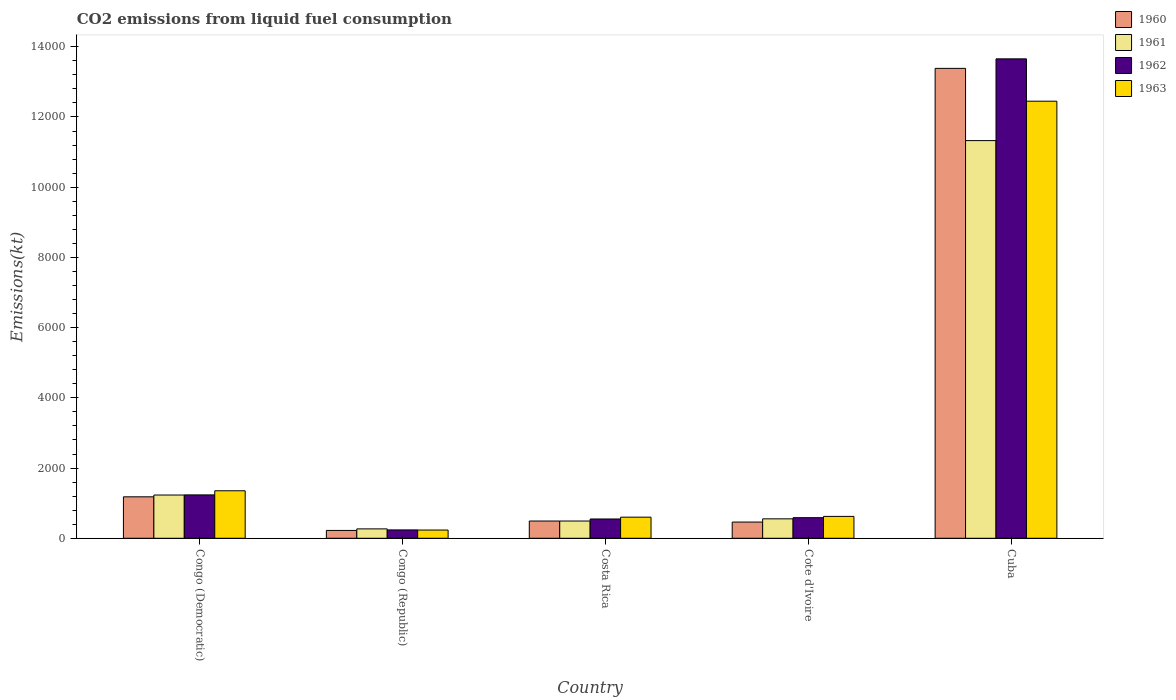How many different coloured bars are there?
Your answer should be very brief. 4. How many groups of bars are there?
Your response must be concise. 5. Are the number of bars per tick equal to the number of legend labels?
Keep it short and to the point. Yes. Are the number of bars on each tick of the X-axis equal?
Give a very brief answer. Yes. What is the label of the 5th group of bars from the left?
Offer a terse response. Cuba. What is the amount of CO2 emitted in 1963 in Congo (Democratic)?
Make the answer very short. 1353.12. Across all countries, what is the maximum amount of CO2 emitted in 1963?
Your answer should be compact. 1.24e+04. Across all countries, what is the minimum amount of CO2 emitted in 1960?
Give a very brief answer. 223.69. In which country was the amount of CO2 emitted in 1963 maximum?
Your answer should be compact. Cuba. In which country was the amount of CO2 emitted in 1961 minimum?
Your answer should be compact. Congo (Republic). What is the total amount of CO2 emitted in 1962 in the graph?
Ensure brevity in your answer.  1.63e+04. What is the difference between the amount of CO2 emitted in 1960 in Congo (Republic) and that in Cuba?
Offer a very short reply. -1.32e+04. What is the difference between the amount of CO2 emitted in 1960 in Cote d'Ivoire and the amount of CO2 emitted in 1963 in Costa Rica?
Provide a short and direct response. -139.35. What is the average amount of CO2 emitted in 1961 per country?
Offer a very short reply. 2774.45. What is the difference between the amount of CO2 emitted of/in 1962 and amount of CO2 emitted of/in 1963 in Cote d'Ivoire?
Your answer should be very brief. -36.67. In how many countries, is the amount of CO2 emitted in 1961 greater than 10000 kt?
Give a very brief answer. 1. What is the ratio of the amount of CO2 emitted in 1961 in Congo (Republic) to that in Cuba?
Ensure brevity in your answer.  0.02. Is the amount of CO2 emitted in 1960 in Costa Rica less than that in Cote d'Ivoire?
Provide a short and direct response. No. What is the difference between the highest and the second highest amount of CO2 emitted in 1961?
Provide a short and direct response. 678.4. What is the difference between the highest and the lowest amount of CO2 emitted in 1962?
Your response must be concise. 1.34e+04. Is the sum of the amount of CO2 emitted in 1963 in Congo (Democratic) and Cote d'Ivoire greater than the maximum amount of CO2 emitted in 1961 across all countries?
Offer a terse response. No. Is it the case that in every country, the sum of the amount of CO2 emitted in 1961 and amount of CO2 emitted in 1963 is greater than the amount of CO2 emitted in 1960?
Offer a very short reply. Yes. How many bars are there?
Keep it short and to the point. 20. Are all the bars in the graph horizontal?
Give a very brief answer. No. How many countries are there in the graph?
Make the answer very short. 5. Does the graph contain any zero values?
Offer a terse response. No. Does the graph contain grids?
Offer a terse response. No. Where does the legend appear in the graph?
Your answer should be very brief. Top right. What is the title of the graph?
Ensure brevity in your answer.  CO2 emissions from liquid fuel consumption. What is the label or title of the Y-axis?
Offer a very short reply. Emissions(kt). What is the Emissions(kt) in 1960 in Congo (Democratic)?
Give a very brief answer. 1180.77. What is the Emissions(kt) of 1961 in Congo (Democratic)?
Offer a very short reply. 1232.11. What is the Emissions(kt) of 1962 in Congo (Democratic)?
Give a very brief answer. 1235.78. What is the Emissions(kt) in 1963 in Congo (Democratic)?
Provide a short and direct response. 1353.12. What is the Emissions(kt) of 1960 in Congo (Republic)?
Your response must be concise. 223.69. What is the Emissions(kt) in 1961 in Congo (Republic)?
Keep it short and to the point. 267.69. What is the Emissions(kt) in 1962 in Congo (Republic)?
Ensure brevity in your answer.  238.35. What is the Emissions(kt) of 1963 in Congo (Republic)?
Keep it short and to the point. 234.69. What is the Emissions(kt) in 1960 in Costa Rica?
Keep it short and to the point. 491.38. What is the Emissions(kt) of 1961 in Costa Rica?
Ensure brevity in your answer.  491.38. What is the Emissions(kt) of 1962 in Costa Rica?
Make the answer very short. 550.05. What is the Emissions(kt) in 1963 in Costa Rica?
Provide a succinct answer. 601.39. What is the Emissions(kt) of 1960 in Cote d'Ivoire?
Your response must be concise. 462.04. What is the Emissions(kt) of 1961 in Cote d'Ivoire?
Offer a very short reply. 553.72. What is the Emissions(kt) of 1962 in Cote d'Ivoire?
Offer a terse response. 586.72. What is the Emissions(kt) of 1963 in Cote d'Ivoire?
Offer a very short reply. 623.39. What is the Emissions(kt) in 1960 in Cuba?
Provide a short and direct response. 1.34e+04. What is the Emissions(kt) of 1961 in Cuba?
Give a very brief answer. 1.13e+04. What is the Emissions(kt) of 1962 in Cuba?
Your answer should be very brief. 1.37e+04. What is the Emissions(kt) in 1963 in Cuba?
Your answer should be very brief. 1.24e+04. Across all countries, what is the maximum Emissions(kt) of 1960?
Ensure brevity in your answer.  1.34e+04. Across all countries, what is the maximum Emissions(kt) of 1961?
Your response must be concise. 1.13e+04. Across all countries, what is the maximum Emissions(kt) in 1962?
Give a very brief answer. 1.37e+04. Across all countries, what is the maximum Emissions(kt) in 1963?
Offer a very short reply. 1.24e+04. Across all countries, what is the minimum Emissions(kt) of 1960?
Offer a very short reply. 223.69. Across all countries, what is the minimum Emissions(kt) in 1961?
Your response must be concise. 267.69. Across all countries, what is the minimum Emissions(kt) in 1962?
Provide a short and direct response. 238.35. Across all countries, what is the minimum Emissions(kt) of 1963?
Your response must be concise. 234.69. What is the total Emissions(kt) in 1960 in the graph?
Keep it short and to the point. 1.57e+04. What is the total Emissions(kt) of 1961 in the graph?
Your answer should be very brief. 1.39e+04. What is the total Emissions(kt) of 1962 in the graph?
Give a very brief answer. 1.63e+04. What is the total Emissions(kt) in 1963 in the graph?
Offer a terse response. 1.53e+04. What is the difference between the Emissions(kt) of 1960 in Congo (Democratic) and that in Congo (Republic)?
Give a very brief answer. 957.09. What is the difference between the Emissions(kt) of 1961 in Congo (Democratic) and that in Congo (Republic)?
Your answer should be very brief. 964.42. What is the difference between the Emissions(kt) in 1962 in Congo (Democratic) and that in Congo (Republic)?
Provide a short and direct response. 997.42. What is the difference between the Emissions(kt) of 1963 in Congo (Democratic) and that in Congo (Republic)?
Ensure brevity in your answer.  1118.43. What is the difference between the Emissions(kt) of 1960 in Congo (Democratic) and that in Costa Rica?
Provide a short and direct response. 689.4. What is the difference between the Emissions(kt) in 1961 in Congo (Democratic) and that in Costa Rica?
Provide a short and direct response. 740.73. What is the difference between the Emissions(kt) of 1962 in Congo (Democratic) and that in Costa Rica?
Make the answer very short. 685.73. What is the difference between the Emissions(kt) in 1963 in Congo (Democratic) and that in Costa Rica?
Ensure brevity in your answer.  751.74. What is the difference between the Emissions(kt) of 1960 in Congo (Democratic) and that in Cote d'Ivoire?
Offer a terse response. 718.73. What is the difference between the Emissions(kt) in 1961 in Congo (Democratic) and that in Cote d'Ivoire?
Offer a terse response. 678.39. What is the difference between the Emissions(kt) of 1962 in Congo (Democratic) and that in Cote d'Ivoire?
Make the answer very short. 649.06. What is the difference between the Emissions(kt) of 1963 in Congo (Democratic) and that in Cote d'Ivoire?
Your answer should be very brief. 729.73. What is the difference between the Emissions(kt) in 1960 in Congo (Democratic) and that in Cuba?
Your answer should be very brief. -1.22e+04. What is the difference between the Emissions(kt) in 1961 in Congo (Democratic) and that in Cuba?
Your answer should be very brief. -1.01e+04. What is the difference between the Emissions(kt) in 1962 in Congo (Democratic) and that in Cuba?
Offer a terse response. -1.24e+04. What is the difference between the Emissions(kt) of 1963 in Congo (Democratic) and that in Cuba?
Make the answer very short. -1.11e+04. What is the difference between the Emissions(kt) of 1960 in Congo (Republic) and that in Costa Rica?
Ensure brevity in your answer.  -267.69. What is the difference between the Emissions(kt) in 1961 in Congo (Republic) and that in Costa Rica?
Offer a terse response. -223.69. What is the difference between the Emissions(kt) in 1962 in Congo (Republic) and that in Costa Rica?
Make the answer very short. -311.69. What is the difference between the Emissions(kt) of 1963 in Congo (Republic) and that in Costa Rica?
Ensure brevity in your answer.  -366.7. What is the difference between the Emissions(kt) in 1960 in Congo (Republic) and that in Cote d'Ivoire?
Your answer should be very brief. -238.35. What is the difference between the Emissions(kt) of 1961 in Congo (Republic) and that in Cote d'Ivoire?
Your answer should be compact. -286.03. What is the difference between the Emissions(kt) in 1962 in Congo (Republic) and that in Cote d'Ivoire?
Make the answer very short. -348.37. What is the difference between the Emissions(kt) of 1963 in Congo (Republic) and that in Cote d'Ivoire?
Offer a very short reply. -388.7. What is the difference between the Emissions(kt) of 1960 in Congo (Republic) and that in Cuba?
Offer a terse response. -1.32e+04. What is the difference between the Emissions(kt) of 1961 in Congo (Republic) and that in Cuba?
Offer a very short reply. -1.11e+04. What is the difference between the Emissions(kt) in 1962 in Congo (Republic) and that in Cuba?
Your answer should be very brief. -1.34e+04. What is the difference between the Emissions(kt) in 1963 in Congo (Republic) and that in Cuba?
Ensure brevity in your answer.  -1.22e+04. What is the difference between the Emissions(kt) in 1960 in Costa Rica and that in Cote d'Ivoire?
Keep it short and to the point. 29.34. What is the difference between the Emissions(kt) in 1961 in Costa Rica and that in Cote d'Ivoire?
Your response must be concise. -62.34. What is the difference between the Emissions(kt) in 1962 in Costa Rica and that in Cote d'Ivoire?
Your answer should be compact. -36.67. What is the difference between the Emissions(kt) of 1963 in Costa Rica and that in Cote d'Ivoire?
Offer a very short reply. -22. What is the difference between the Emissions(kt) of 1960 in Costa Rica and that in Cuba?
Ensure brevity in your answer.  -1.29e+04. What is the difference between the Emissions(kt) of 1961 in Costa Rica and that in Cuba?
Your response must be concise. -1.08e+04. What is the difference between the Emissions(kt) in 1962 in Costa Rica and that in Cuba?
Your answer should be compact. -1.31e+04. What is the difference between the Emissions(kt) of 1963 in Costa Rica and that in Cuba?
Offer a very short reply. -1.18e+04. What is the difference between the Emissions(kt) of 1960 in Cote d'Ivoire and that in Cuba?
Offer a very short reply. -1.29e+04. What is the difference between the Emissions(kt) of 1961 in Cote d'Ivoire and that in Cuba?
Your answer should be very brief. -1.08e+04. What is the difference between the Emissions(kt) in 1962 in Cote d'Ivoire and that in Cuba?
Ensure brevity in your answer.  -1.31e+04. What is the difference between the Emissions(kt) of 1963 in Cote d'Ivoire and that in Cuba?
Your answer should be very brief. -1.18e+04. What is the difference between the Emissions(kt) in 1960 in Congo (Democratic) and the Emissions(kt) in 1961 in Congo (Republic)?
Ensure brevity in your answer.  913.08. What is the difference between the Emissions(kt) in 1960 in Congo (Democratic) and the Emissions(kt) in 1962 in Congo (Republic)?
Give a very brief answer. 942.42. What is the difference between the Emissions(kt) of 1960 in Congo (Democratic) and the Emissions(kt) of 1963 in Congo (Republic)?
Your answer should be compact. 946.09. What is the difference between the Emissions(kt) of 1961 in Congo (Democratic) and the Emissions(kt) of 1962 in Congo (Republic)?
Provide a short and direct response. 993.76. What is the difference between the Emissions(kt) of 1961 in Congo (Democratic) and the Emissions(kt) of 1963 in Congo (Republic)?
Ensure brevity in your answer.  997.42. What is the difference between the Emissions(kt) of 1962 in Congo (Democratic) and the Emissions(kt) of 1963 in Congo (Republic)?
Provide a succinct answer. 1001.09. What is the difference between the Emissions(kt) in 1960 in Congo (Democratic) and the Emissions(kt) in 1961 in Costa Rica?
Your answer should be compact. 689.4. What is the difference between the Emissions(kt) in 1960 in Congo (Democratic) and the Emissions(kt) in 1962 in Costa Rica?
Provide a succinct answer. 630.72. What is the difference between the Emissions(kt) in 1960 in Congo (Democratic) and the Emissions(kt) in 1963 in Costa Rica?
Provide a short and direct response. 579.39. What is the difference between the Emissions(kt) in 1961 in Congo (Democratic) and the Emissions(kt) in 1962 in Costa Rica?
Make the answer very short. 682.06. What is the difference between the Emissions(kt) in 1961 in Congo (Democratic) and the Emissions(kt) in 1963 in Costa Rica?
Your response must be concise. 630.72. What is the difference between the Emissions(kt) in 1962 in Congo (Democratic) and the Emissions(kt) in 1963 in Costa Rica?
Your answer should be compact. 634.39. What is the difference between the Emissions(kt) of 1960 in Congo (Democratic) and the Emissions(kt) of 1961 in Cote d'Ivoire?
Offer a terse response. 627.06. What is the difference between the Emissions(kt) in 1960 in Congo (Democratic) and the Emissions(kt) in 1962 in Cote d'Ivoire?
Give a very brief answer. 594.05. What is the difference between the Emissions(kt) of 1960 in Congo (Democratic) and the Emissions(kt) of 1963 in Cote d'Ivoire?
Your response must be concise. 557.38. What is the difference between the Emissions(kt) of 1961 in Congo (Democratic) and the Emissions(kt) of 1962 in Cote d'Ivoire?
Provide a succinct answer. 645.39. What is the difference between the Emissions(kt) of 1961 in Congo (Democratic) and the Emissions(kt) of 1963 in Cote d'Ivoire?
Offer a terse response. 608.72. What is the difference between the Emissions(kt) in 1962 in Congo (Democratic) and the Emissions(kt) in 1963 in Cote d'Ivoire?
Keep it short and to the point. 612.39. What is the difference between the Emissions(kt) of 1960 in Congo (Democratic) and the Emissions(kt) of 1961 in Cuba?
Ensure brevity in your answer.  -1.01e+04. What is the difference between the Emissions(kt) in 1960 in Congo (Democratic) and the Emissions(kt) in 1962 in Cuba?
Provide a short and direct response. -1.25e+04. What is the difference between the Emissions(kt) of 1960 in Congo (Democratic) and the Emissions(kt) of 1963 in Cuba?
Provide a short and direct response. -1.13e+04. What is the difference between the Emissions(kt) of 1961 in Congo (Democratic) and the Emissions(kt) of 1962 in Cuba?
Give a very brief answer. -1.24e+04. What is the difference between the Emissions(kt) of 1961 in Congo (Democratic) and the Emissions(kt) of 1963 in Cuba?
Your response must be concise. -1.12e+04. What is the difference between the Emissions(kt) of 1962 in Congo (Democratic) and the Emissions(kt) of 1963 in Cuba?
Keep it short and to the point. -1.12e+04. What is the difference between the Emissions(kt) of 1960 in Congo (Republic) and the Emissions(kt) of 1961 in Costa Rica?
Provide a succinct answer. -267.69. What is the difference between the Emissions(kt) of 1960 in Congo (Republic) and the Emissions(kt) of 1962 in Costa Rica?
Your answer should be very brief. -326.36. What is the difference between the Emissions(kt) of 1960 in Congo (Republic) and the Emissions(kt) of 1963 in Costa Rica?
Your answer should be compact. -377.7. What is the difference between the Emissions(kt) in 1961 in Congo (Republic) and the Emissions(kt) in 1962 in Costa Rica?
Offer a very short reply. -282.36. What is the difference between the Emissions(kt) of 1961 in Congo (Republic) and the Emissions(kt) of 1963 in Costa Rica?
Offer a very short reply. -333.7. What is the difference between the Emissions(kt) in 1962 in Congo (Republic) and the Emissions(kt) in 1963 in Costa Rica?
Ensure brevity in your answer.  -363.03. What is the difference between the Emissions(kt) of 1960 in Congo (Republic) and the Emissions(kt) of 1961 in Cote d'Ivoire?
Offer a very short reply. -330.03. What is the difference between the Emissions(kt) of 1960 in Congo (Republic) and the Emissions(kt) of 1962 in Cote d'Ivoire?
Provide a succinct answer. -363.03. What is the difference between the Emissions(kt) in 1960 in Congo (Republic) and the Emissions(kt) in 1963 in Cote d'Ivoire?
Your answer should be very brief. -399.7. What is the difference between the Emissions(kt) of 1961 in Congo (Republic) and the Emissions(kt) of 1962 in Cote d'Ivoire?
Provide a short and direct response. -319.03. What is the difference between the Emissions(kt) in 1961 in Congo (Republic) and the Emissions(kt) in 1963 in Cote d'Ivoire?
Your response must be concise. -355.7. What is the difference between the Emissions(kt) of 1962 in Congo (Republic) and the Emissions(kt) of 1963 in Cote d'Ivoire?
Your answer should be compact. -385.04. What is the difference between the Emissions(kt) in 1960 in Congo (Republic) and the Emissions(kt) in 1961 in Cuba?
Provide a succinct answer. -1.11e+04. What is the difference between the Emissions(kt) of 1960 in Congo (Republic) and the Emissions(kt) of 1962 in Cuba?
Offer a terse response. -1.34e+04. What is the difference between the Emissions(kt) of 1960 in Congo (Republic) and the Emissions(kt) of 1963 in Cuba?
Make the answer very short. -1.22e+04. What is the difference between the Emissions(kt) of 1961 in Congo (Republic) and the Emissions(kt) of 1962 in Cuba?
Provide a succinct answer. -1.34e+04. What is the difference between the Emissions(kt) of 1961 in Congo (Republic) and the Emissions(kt) of 1963 in Cuba?
Offer a terse response. -1.22e+04. What is the difference between the Emissions(kt) in 1962 in Congo (Republic) and the Emissions(kt) in 1963 in Cuba?
Provide a short and direct response. -1.22e+04. What is the difference between the Emissions(kt) of 1960 in Costa Rica and the Emissions(kt) of 1961 in Cote d'Ivoire?
Provide a succinct answer. -62.34. What is the difference between the Emissions(kt) of 1960 in Costa Rica and the Emissions(kt) of 1962 in Cote d'Ivoire?
Make the answer very short. -95.34. What is the difference between the Emissions(kt) of 1960 in Costa Rica and the Emissions(kt) of 1963 in Cote d'Ivoire?
Give a very brief answer. -132.01. What is the difference between the Emissions(kt) in 1961 in Costa Rica and the Emissions(kt) in 1962 in Cote d'Ivoire?
Give a very brief answer. -95.34. What is the difference between the Emissions(kt) in 1961 in Costa Rica and the Emissions(kt) in 1963 in Cote d'Ivoire?
Offer a very short reply. -132.01. What is the difference between the Emissions(kt) of 1962 in Costa Rica and the Emissions(kt) of 1963 in Cote d'Ivoire?
Offer a very short reply. -73.34. What is the difference between the Emissions(kt) of 1960 in Costa Rica and the Emissions(kt) of 1961 in Cuba?
Provide a succinct answer. -1.08e+04. What is the difference between the Emissions(kt) of 1960 in Costa Rica and the Emissions(kt) of 1962 in Cuba?
Provide a succinct answer. -1.32e+04. What is the difference between the Emissions(kt) in 1960 in Costa Rica and the Emissions(kt) in 1963 in Cuba?
Your answer should be very brief. -1.20e+04. What is the difference between the Emissions(kt) in 1961 in Costa Rica and the Emissions(kt) in 1962 in Cuba?
Offer a terse response. -1.32e+04. What is the difference between the Emissions(kt) in 1961 in Costa Rica and the Emissions(kt) in 1963 in Cuba?
Offer a very short reply. -1.20e+04. What is the difference between the Emissions(kt) of 1962 in Costa Rica and the Emissions(kt) of 1963 in Cuba?
Your response must be concise. -1.19e+04. What is the difference between the Emissions(kt) in 1960 in Cote d'Ivoire and the Emissions(kt) in 1961 in Cuba?
Provide a short and direct response. -1.09e+04. What is the difference between the Emissions(kt) in 1960 in Cote d'Ivoire and the Emissions(kt) in 1962 in Cuba?
Your response must be concise. -1.32e+04. What is the difference between the Emissions(kt) in 1960 in Cote d'Ivoire and the Emissions(kt) in 1963 in Cuba?
Give a very brief answer. -1.20e+04. What is the difference between the Emissions(kt) of 1961 in Cote d'Ivoire and the Emissions(kt) of 1962 in Cuba?
Provide a short and direct response. -1.31e+04. What is the difference between the Emissions(kt) in 1961 in Cote d'Ivoire and the Emissions(kt) in 1963 in Cuba?
Your response must be concise. -1.19e+04. What is the difference between the Emissions(kt) in 1962 in Cote d'Ivoire and the Emissions(kt) in 1963 in Cuba?
Give a very brief answer. -1.19e+04. What is the average Emissions(kt) of 1960 per country?
Offer a terse response. 3148.49. What is the average Emissions(kt) of 1961 per country?
Provide a succinct answer. 2774.45. What is the average Emissions(kt) in 1962 per country?
Ensure brevity in your answer.  3253.36. What is the average Emissions(kt) in 1963 per country?
Keep it short and to the point. 3052.41. What is the difference between the Emissions(kt) of 1960 and Emissions(kt) of 1961 in Congo (Democratic)?
Offer a terse response. -51.34. What is the difference between the Emissions(kt) of 1960 and Emissions(kt) of 1962 in Congo (Democratic)?
Provide a short and direct response. -55.01. What is the difference between the Emissions(kt) in 1960 and Emissions(kt) in 1963 in Congo (Democratic)?
Keep it short and to the point. -172.35. What is the difference between the Emissions(kt) in 1961 and Emissions(kt) in 1962 in Congo (Democratic)?
Your answer should be compact. -3.67. What is the difference between the Emissions(kt) in 1961 and Emissions(kt) in 1963 in Congo (Democratic)?
Give a very brief answer. -121.01. What is the difference between the Emissions(kt) in 1962 and Emissions(kt) in 1963 in Congo (Democratic)?
Give a very brief answer. -117.34. What is the difference between the Emissions(kt) of 1960 and Emissions(kt) of 1961 in Congo (Republic)?
Make the answer very short. -44. What is the difference between the Emissions(kt) in 1960 and Emissions(kt) in 1962 in Congo (Republic)?
Give a very brief answer. -14.67. What is the difference between the Emissions(kt) of 1960 and Emissions(kt) of 1963 in Congo (Republic)?
Provide a succinct answer. -11. What is the difference between the Emissions(kt) of 1961 and Emissions(kt) of 1962 in Congo (Republic)?
Ensure brevity in your answer.  29.34. What is the difference between the Emissions(kt) in 1961 and Emissions(kt) in 1963 in Congo (Republic)?
Make the answer very short. 33. What is the difference between the Emissions(kt) of 1962 and Emissions(kt) of 1963 in Congo (Republic)?
Ensure brevity in your answer.  3.67. What is the difference between the Emissions(kt) of 1960 and Emissions(kt) of 1962 in Costa Rica?
Your answer should be compact. -58.67. What is the difference between the Emissions(kt) of 1960 and Emissions(kt) of 1963 in Costa Rica?
Offer a very short reply. -110.01. What is the difference between the Emissions(kt) in 1961 and Emissions(kt) in 1962 in Costa Rica?
Offer a very short reply. -58.67. What is the difference between the Emissions(kt) of 1961 and Emissions(kt) of 1963 in Costa Rica?
Keep it short and to the point. -110.01. What is the difference between the Emissions(kt) in 1962 and Emissions(kt) in 1963 in Costa Rica?
Offer a very short reply. -51.34. What is the difference between the Emissions(kt) of 1960 and Emissions(kt) of 1961 in Cote d'Ivoire?
Your answer should be very brief. -91.67. What is the difference between the Emissions(kt) of 1960 and Emissions(kt) of 1962 in Cote d'Ivoire?
Your answer should be very brief. -124.68. What is the difference between the Emissions(kt) of 1960 and Emissions(kt) of 1963 in Cote d'Ivoire?
Your answer should be very brief. -161.35. What is the difference between the Emissions(kt) of 1961 and Emissions(kt) of 1962 in Cote d'Ivoire?
Give a very brief answer. -33. What is the difference between the Emissions(kt) in 1961 and Emissions(kt) in 1963 in Cote d'Ivoire?
Your response must be concise. -69.67. What is the difference between the Emissions(kt) of 1962 and Emissions(kt) of 1963 in Cote d'Ivoire?
Give a very brief answer. -36.67. What is the difference between the Emissions(kt) of 1960 and Emissions(kt) of 1961 in Cuba?
Provide a short and direct response. 2057.19. What is the difference between the Emissions(kt) of 1960 and Emissions(kt) of 1962 in Cuba?
Provide a succinct answer. -271.36. What is the difference between the Emissions(kt) of 1960 and Emissions(kt) of 1963 in Cuba?
Offer a terse response. 935.09. What is the difference between the Emissions(kt) in 1961 and Emissions(kt) in 1962 in Cuba?
Offer a terse response. -2328.55. What is the difference between the Emissions(kt) of 1961 and Emissions(kt) of 1963 in Cuba?
Offer a very short reply. -1122.1. What is the difference between the Emissions(kt) in 1962 and Emissions(kt) in 1963 in Cuba?
Keep it short and to the point. 1206.44. What is the ratio of the Emissions(kt) in 1960 in Congo (Democratic) to that in Congo (Republic)?
Your response must be concise. 5.28. What is the ratio of the Emissions(kt) in 1961 in Congo (Democratic) to that in Congo (Republic)?
Provide a short and direct response. 4.6. What is the ratio of the Emissions(kt) in 1962 in Congo (Democratic) to that in Congo (Republic)?
Your answer should be compact. 5.18. What is the ratio of the Emissions(kt) of 1963 in Congo (Democratic) to that in Congo (Republic)?
Provide a short and direct response. 5.77. What is the ratio of the Emissions(kt) of 1960 in Congo (Democratic) to that in Costa Rica?
Make the answer very short. 2.4. What is the ratio of the Emissions(kt) of 1961 in Congo (Democratic) to that in Costa Rica?
Offer a very short reply. 2.51. What is the ratio of the Emissions(kt) in 1962 in Congo (Democratic) to that in Costa Rica?
Provide a succinct answer. 2.25. What is the ratio of the Emissions(kt) in 1963 in Congo (Democratic) to that in Costa Rica?
Ensure brevity in your answer.  2.25. What is the ratio of the Emissions(kt) in 1960 in Congo (Democratic) to that in Cote d'Ivoire?
Keep it short and to the point. 2.56. What is the ratio of the Emissions(kt) in 1961 in Congo (Democratic) to that in Cote d'Ivoire?
Provide a succinct answer. 2.23. What is the ratio of the Emissions(kt) in 1962 in Congo (Democratic) to that in Cote d'Ivoire?
Offer a very short reply. 2.11. What is the ratio of the Emissions(kt) in 1963 in Congo (Democratic) to that in Cote d'Ivoire?
Provide a succinct answer. 2.17. What is the ratio of the Emissions(kt) in 1960 in Congo (Democratic) to that in Cuba?
Your answer should be very brief. 0.09. What is the ratio of the Emissions(kt) in 1961 in Congo (Democratic) to that in Cuba?
Your answer should be very brief. 0.11. What is the ratio of the Emissions(kt) of 1962 in Congo (Democratic) to that in Cuba?
Your answer should be compact. 0.09. What is the ratio of the Emissions(kt) of 1963 in Congo (Democratic) to that in Cuba?
Offer a terse response. 0.11. What is the ratio of the Emissions(kt) in 1960 in Congo (Republic) to that in Costa Rica?
Ensure brevity in your answer.  0.46. What is the ratio of the Emissions(kt) in 1961 in Congo (Republic) to that in Costa Rica?
Your answer should be very brief. 0.54. What is the ratio of the Emissions(kt) of 1962 in Congo (Republic) to that in Costa Rica?
Your answer should be very brief. 0.43. What is the ratio of the Emissions(kt) of 1963 in Congo (Republic) to that in Costa Rica?
Give a very brief answer. 0.39. What is the ratio of the Emissions(kt) of 1960 in Congo (Republic) to that in Cote d'Ivoire?
Provide a short and direct response. 0.48. What is the ratio of the Emissions(kt) in 1961 in Congo (Republic) to that in Cote d'Ivoire?
Offer a terse response. 0.48. What is the ratio of the Emissions(kt) in 1962 in Congo (Republic) to that in Cote d'Ivoire?
Make the answer very short. 0.41. What is the ratio of the Emissions(kt) in 1963 in Congo (Republic) to that in Cote d'Ivoire?
Offer a very short reply. 0.38. What is the ratio of the Emissions(kt) in 1960 in Congo (Republic) to that in Cuba?
Your response must be concise. 0.02. What is the ratio of the Emissions(kt) in 1961 in Congo (Republic) to that in Cuba?
Keep it short and to the point. 0.02. What is the ratio of the Emissions(kt) of 1962 in Congo (Republic) to that in Cuba?
Keep it short and to the point. 0.02. What is the ratio of the Emissions(kt) of 1963 in Congo (Republic) to that in Cuba?
Your response must be concise. 0.02. What is the ratio of the Emissions(kt) in 1960 in Costa Rica to that in Cote d'Ivoire?
Provide a short and direct response. 1.06. What is the ratio of the Emissions(kt) in 1961 in Costa Rica to that in Cote d'Ivoire?
Keep it short and to the point. 0.89. What is the ratio of the Emissions(kt) in 1962 in Costa Rica to that in Cote d'Ivoire?
Your answer should be compact. 0.94. What is the ratio of the Emissions(kt) in 1963 in Costa Rica to that in Cote d'Ivoire?
Your response must be concise. 0.96. What is the ratio of the Emissions(kt) in 1960 in Costa Rica to that in Cuba?
Your response must be concise. 0.04. What is the ratio of the Emissions(kt) of 1961 in Costa Rica to that in Cuba?
Your answer should be very brief. 0.04. What is the ratio of the Emissions(kt) of 1962 in Costa Rica to that in Cuba?
Provide a short and direct response. 0.04. What is the ratio of the Emissions(kt) in 1963 in Costa Rica to that in Cuba?
Your response must be concise. 0.05. What is the ratio of the Emissions(kt) in 1960 in Cote d'Ivoire to that in Cuba?
Provide a succinct answer. 0.03. What is the ratio of the Emissions(kt) of 1961 in Cote d'Ivoire to that in Cuba?
Provide a short and direct response. 0.05. What is the ratio of the Emissions(kt) in 1962 in Cote d'Ivoire to that in Cuba?
Ensure brevity in your answer.  0.04. What is the ratio of the Emissions(kt) in 1963 in Cote d'Ivoire to that in Cuba?
Provide a succinct answer. 0.05. What is the difference between the highest and the second highest Emissions(kt) of 1960?
Offer a very short reply. 1.22e+04. What is the difference between the highest and the second highest Emissions(kt) of 1961?
Make the answer very short. 1.01e+04. What is the difference between the highest and the second highest Emissions(kt) of 1962?
Give a very brief answer. 1.24e+04. What is the difference between the highest and the second highest Emissions(kt) of 1963?
Your response must be concise. 1.11e+04. What is the difference between the highest and the lowest Emissions(kt) of 1960?
Offer a very short reply. 1.32e+04. What is the difference between the highest and the lowest Emissions(kt) in 1961?
Keep it short and to the point. 1.11e+04. What is the difference between the highest and the lowest Emissions(kt) of 1962?
Your answer should be compact. 1.34e+04. What is the difference between the highest and the lowest Emissions(kt) in 1963?
Ensure brevity in your answer.  1.22e+04. 